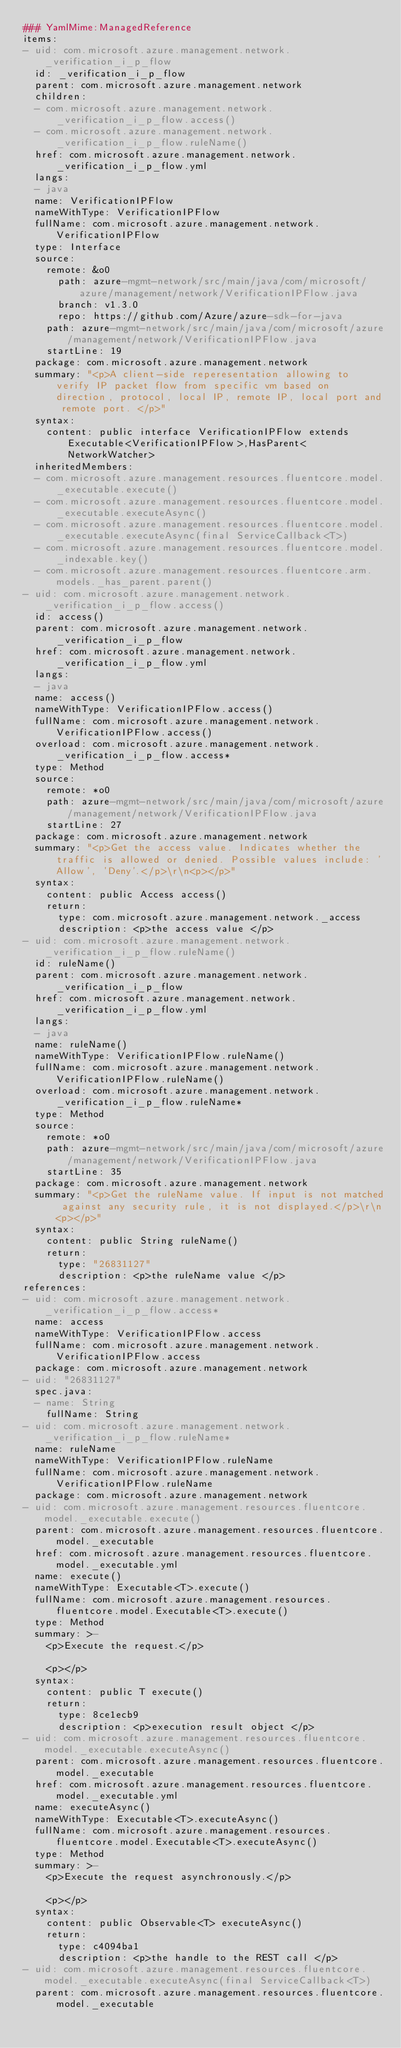<code> <loc_0><loc_0><loc_500><loc_500><_YAML_>### YamlMime:ManagedReference
items:
- uid: com.microsoft.azure.management.network._verification_i_p_flow
  id: _verification_i_p_flow
  parent: com.microsoft.azure.management.network
  children:
  - com.microsoft.azure.management.network._verification_i_p_flow.access()
  - com.microsoft.azure.management.network._verification_i_p_flow.ruleName()
  href: com.microsoft.azure.management.network._verification_i_p_flow.yml
  langs:
  - java
  name: VerificationIPFlow
  nameWithType: VerificationIPFlow
  fullName: com.microsoft.azure.management.network.VerificationIPFlow
  type: Interface
  source:
    remote: &o0
      path: azure-mgmt-network/src/main/java/com/microsoft/azure/management/network/VerificationIPFlow.java
      branch: v1.3.0
      repo: https://github.com/Azure/azure-sdk-for-java
    path: azure-mgmt-network/src/main/java/com/microsoft/azure/management/network/VerificationIPFlow.java
    startLine: 19
  package: com.microsoft.azure.management.network
  summary: "<p>A client-side reperesentation allowing to verify IP packet flow from specific vm based on direction, protocol, local IP, remote IP, local port and remote port. </p>"
  syntax:
    content: public interface VerificationIPFlow extends Executable<VerificationIPFlow>,HasParent<NetworkWatcher>
  inheritedMembers:
  - com.microsoft.azure.management.resources.fluentcore.model._executable.execute()
  - com.microsoft.azure.management.resources.fluentcore.model._executable.executeAsync()
  - com.microsoft.azure.management.resources.fluentcore.model._executable.executeAsync(final ServiceCallback<T>)
  - com.microsoft.azure.management.resources.fluentcore.model._indexable.key()
  - com.microsoft.azure.management.resources.fluentcore.arm.models._has_parent.parent()
- uid: com.microsoft.azure.management.network._verification_i_p_flow.access()
  id: access()
  parent: com.microsoft.azure.management.network._verification_i_p_flow
  href: com.microsoft.azure.management.network._verification_i_p_flow.yml
  langs:
  - java
  name: access()
  nameWithType: VerificationIPFlow.access()
  fullName: com.microsoft.azure.management.network.VerificationIPFlow.access()
  overload: com.microsoft.azure.management.network._verification_i_p_flow.access*
  type: Method
  source:
    remote: *o0
    path: azure-mgmt-network/src/main/java/com/microsoft/azure/management/network/VerificationIPFlow.java
    startLine: 27
  package: com.microsoft.azure.management.network
  summary: "<p>Get the access value. Indicates whether the traffic is allowed or denied. Possible values include: 'Allow', 'Deny'.</p>\r\n<p></p>"
  syntax:
    content: public Access access()
    return:
      type: com.microsoft.azure.management.network._access
      description: <p>the access value </p>
- uid: com.microsoft.azure.management.network._verification_i_p_flow.ruleName()
  id: ruleName()
  parent: com.microsoft.azure.management.network._verification_i_p_flow
  href: com.microsoft.azure.management.network._verification_i_p_flow.yml
  langs:
  - java
  name: ruleName()
  nameWithType: VerificationIPFlow.ruleName()
  fullName: com.microsoft.azure.management.network.VerificationIPFlow.ruleName()
  overload: com.microsoft.azure.management.network._verification_i_p_flow.ruleName*
  type: Method
  source:
    remote: *o0
    path: azure-mgmt-network/src/main/java/com/microsoft/azure/management/network/VerificationIPFlow.java
    startLine: 35
  package: com.microsoft.azure.management.network
  summary: "<p>Get the ruleName value. If input is not matched against any security rule, it is not displayed.</p>\r\n<p></p>"
  syntax:
    content: public String ruleName()
    return:
      type: "26831127"
      description: <p>the ruleName value </p>
references:
- uid: com.microsoft.azure.management.network._verification_i_p_flow.access*
  name: access
  nameWithType: VerificationIPFlow.access
  fullName: com.microsoft.azure.management.network.VerificationIPFlow.access
  package: com.microsoft.azure.management.network
- uid: "26831127"
  spec.java:
  - name: String
    fullName: String
- uid: com.microsoft.azure.management.network._verification_i_p_flow.ruleName*
  name: ruleName
  nameWithType: VerificationIPFlow.ruleName
  fullName: com.microsoft.azure.management.network.VerificationIPFlow.ruleName
  package: com.microsoft.azure.management.network
- uid: com.microsoft.azure.management.resources.fluentcore.model._executable.execute()
  parent: com.microsoft.azure.management.resources.fluentcore.model._executable
  href: com.microsoft.azure.management.resources.fluentcore.model._executable.yml
  name: execute()
  nameWithType: Executable<T>.execute()
  fullName: com.microsoft.azure.management.resources.fluentcore.model.Executable<T>.execute()
  type: Method
  summary: >-
    <p>Execute the request.</p>

    <p></p>
  syntax:
    content: public T execute()
    return:
      type: 8ce1ecb9
      description: <p>execution result object </p>
- uid: com.microsoft.azure.management.resources.fluentcore.model._executable.executeAsync()
  parent: com.microsoft.azure.management.resources.fluentcore.model._executable
  href: com.microsoft.azure.management.resources.fluentcore.model._executable.yml
  name: executeAsync()
  nameWithType: Executable<T>.executeAsync()
  fullName: com.microsoft.azure.management.resources.fluentcore.model.Executable<T>.executeAsync()
  type: Method
  summary: >-
    <p>Execute the request asynchronously.</p>

    <p></p>
  syntax:
    content: public Observable<T> executeAsync()
    return:
      type: c4094ba1
      description: <p>the handle to the REST call </p>
- uid: com.microsoft.azure.management.resources.fluentcore.model._executable.executeAsync(final ServiceCallback<T>)
  parent: com.microsoft.azure.management.resources.fluentcore.model._executable</code> 